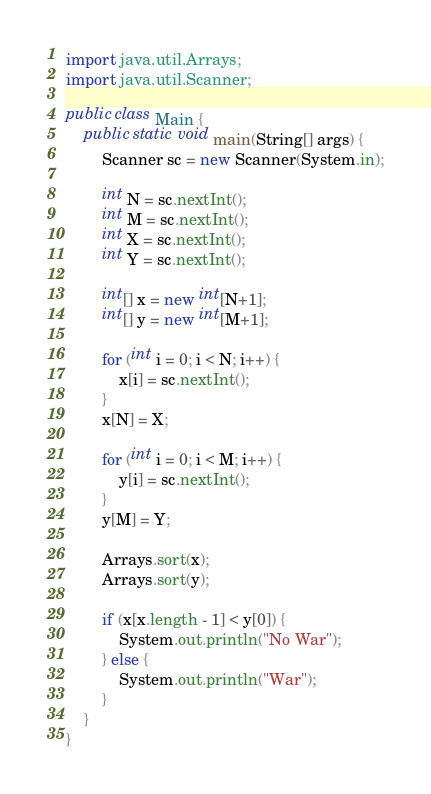Convert code to text. <code><loc_0><loc_0><loc_500><loc_500><_Java_>import java.util.Arrays;
import java.util.Scanner;

public class Main {
    public static void main(String[] args) {
        Scanner sc = new Scanner(System.in);

        int N = sc.nextInt();
        int M = sc.nextInt();
        int X = sc.nextInt();
        int Y = sc.nextInt();

        int[] x = new int[N+1];
        int[] y = new int[M+1];

        for (int i = 0; i < N; i++) {
            x[i] = sc.nextInt();
        }
        x[N] = X;

        for (int i = 0; i < M; i++) {
            y[i] = sc.nextInt();
        }
        y[M] = Y;

        Arrays.sort(x);
        Arrays.sort(y);

        if (x[x.length - 1] < y[0]) {
            System.out.println("No War");
        } else {
            System.out.println("War");
        }
    }
}</code> 